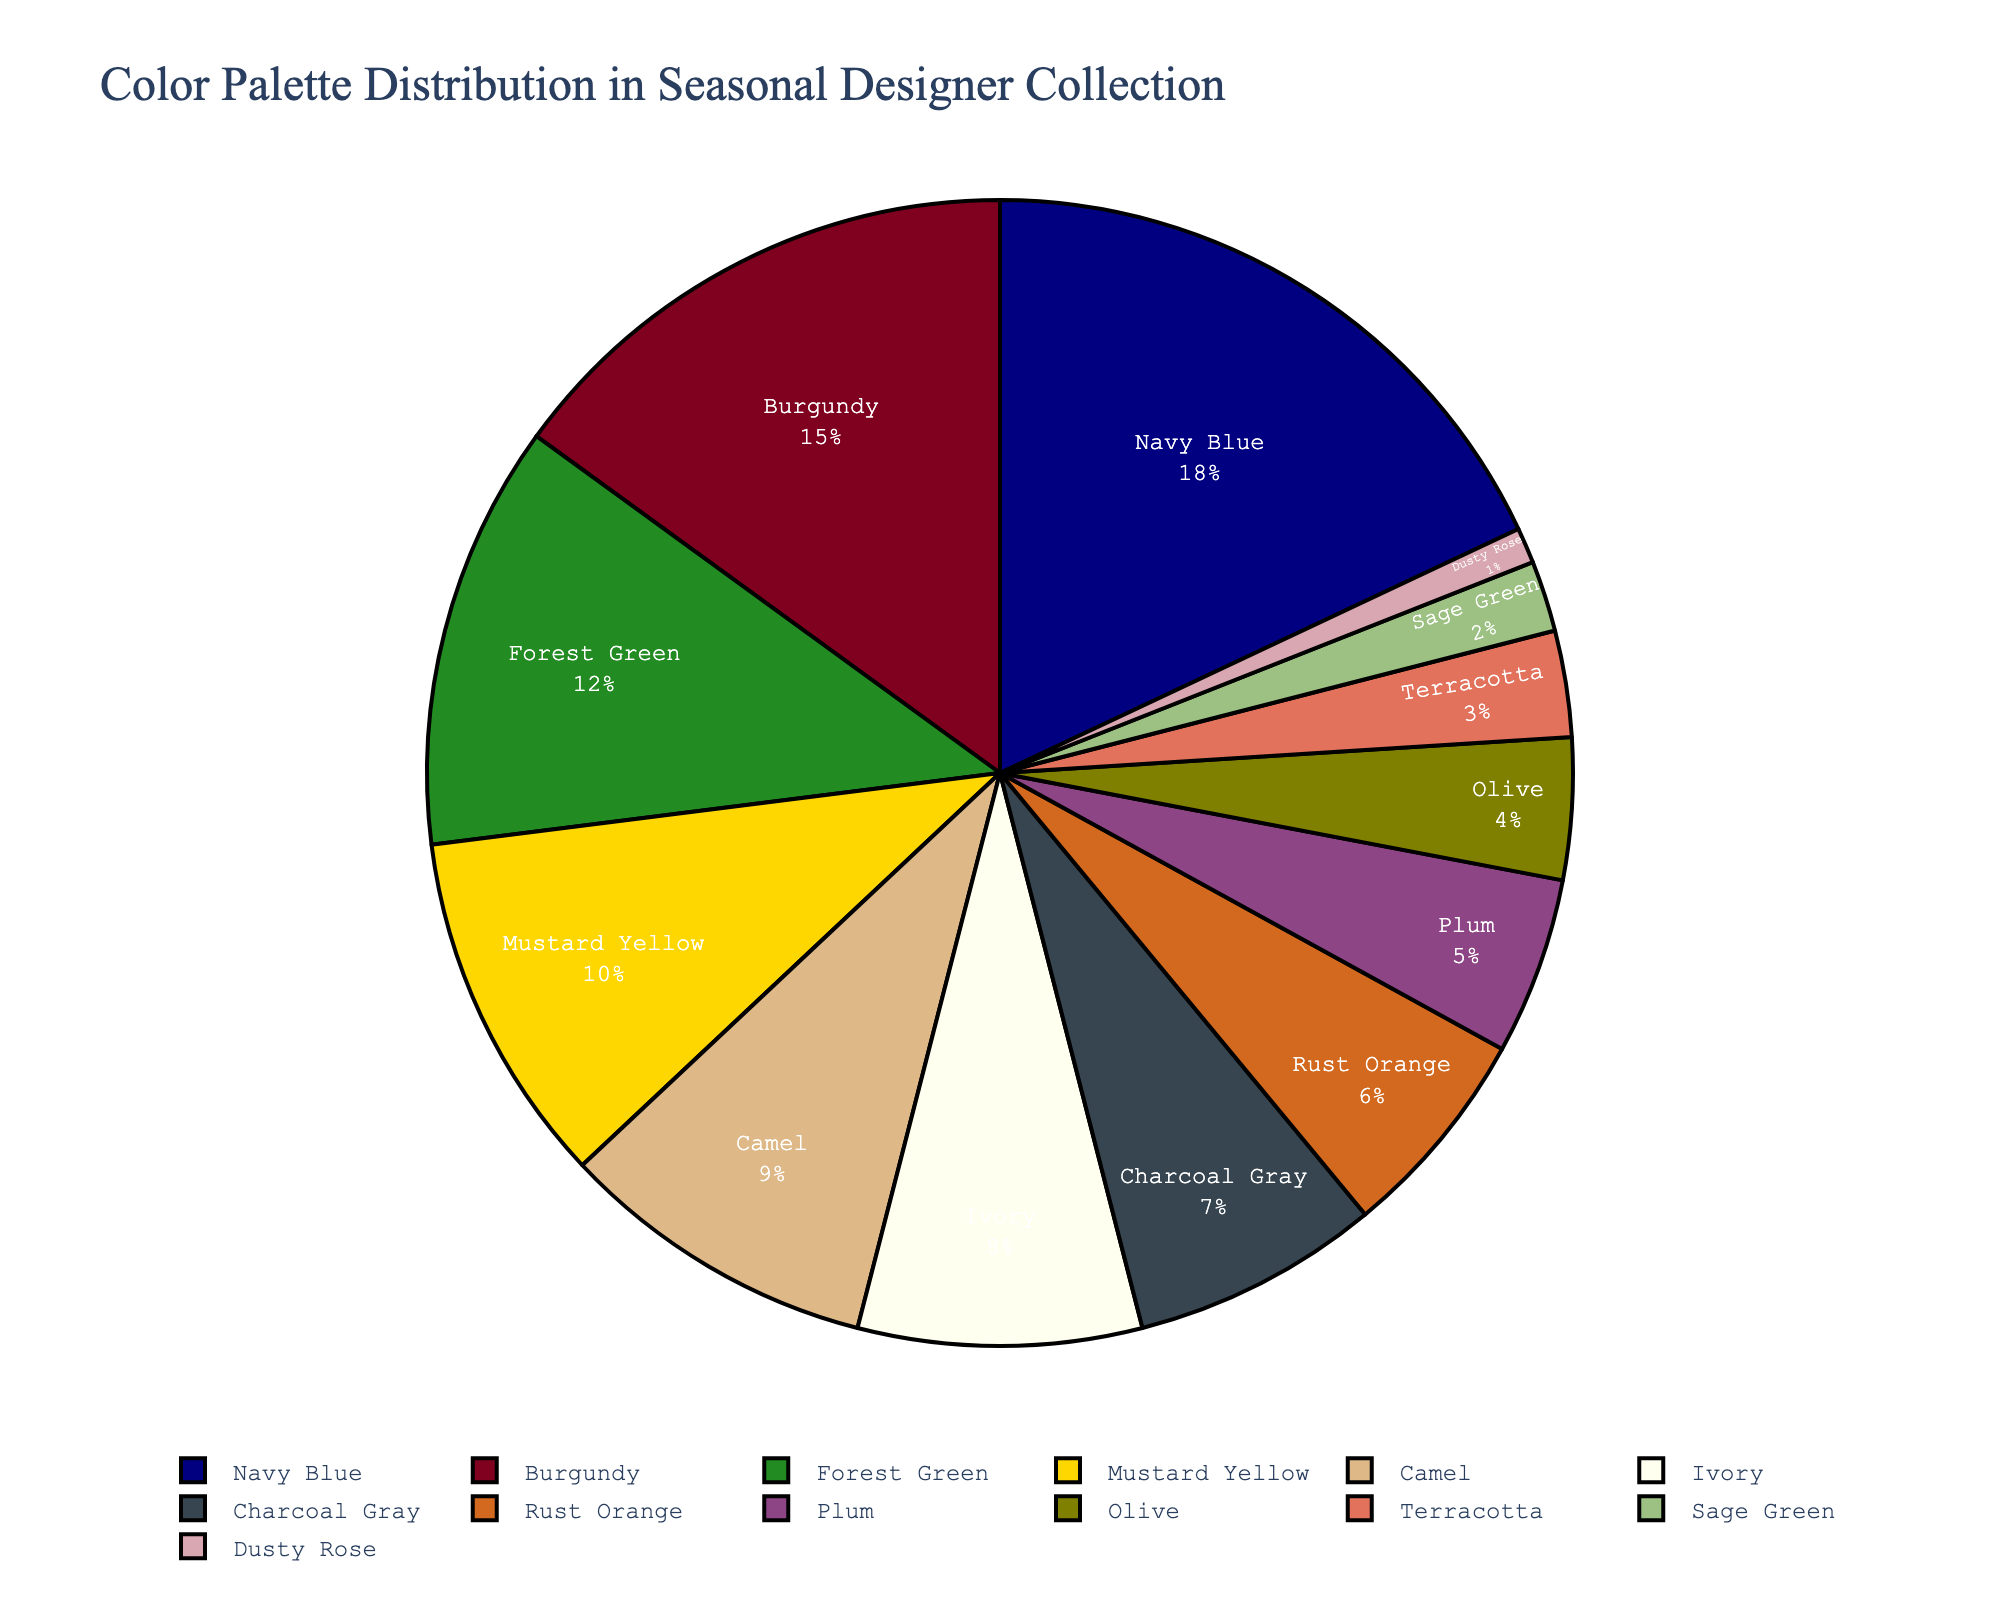Which color has the highest representation in the collection? The pie chart shows the percentage distribution, and Navy Blue is the largest segment with 18%.
Answer: Navy Blue What is the combined percentage of Navy Blue and Burgundy? Navy Blue is 18% and Burgundy is 15%. Summing these gives 18 + 15 = 33%.
Answer: 33% How many colors have a percentage greater than 10%? From the pie chart, Navy Blue (18%), Burgundy (15%), Forest Green (12%), and Mustard Yellow (10%) have percentages above or equal to 10%. Counting these gives 4 colors.
Answer: 4 Which colors combined make up the smallest percentage? Sage Green (2%) and Dusty Rose (1%) are the smallest segments. Their combined percentage is 2 + 1 = 3%.
Answer: Sage Green and Dusty Rose What is the percentage difference between Mustard Yellow and Rust Orange? Mustard Yellow is 10% and Rust Orange is 6%. The difference is 10 - 6 = 4%.
Answer: 4% Which two colors combined make up a percentage close to 20%? Burgundy (15%) and Olive (4%) together make 15 + 4 = 19%, which is close to 20%.
Answer: Burgundy and Olive Which color segment appears the least? The smallest segment by percentage is Dusty Rose, which is 1%.
Answer: Dusty Rose What is the percentage of colors represented by neutrals (Camel, Ivory, Charcoal Gray, and Sage Green)? Camel is 9%, Ivory is 8%, Charcoal Gray is 7%, and Sage Green is 2%. Summing these gives 9 + 8 + 7 + 2 = 26%.
Answer: 26% Compare the sizes of Plum and Olive. Which is greater and by how much? Plum is 5% and Olive is 4%. Plum is greater by 5 - 4 = 1%.
Answer: Plum by 1% How many colors are represented by a percentage smaller than 5%? Plum (5%), Olive (4%), Terracotta (3%), Sage Green (2%), and Dusty Rose (1%) have smaller than 5%. Counting these gives 5 colors.
Answer: 5 